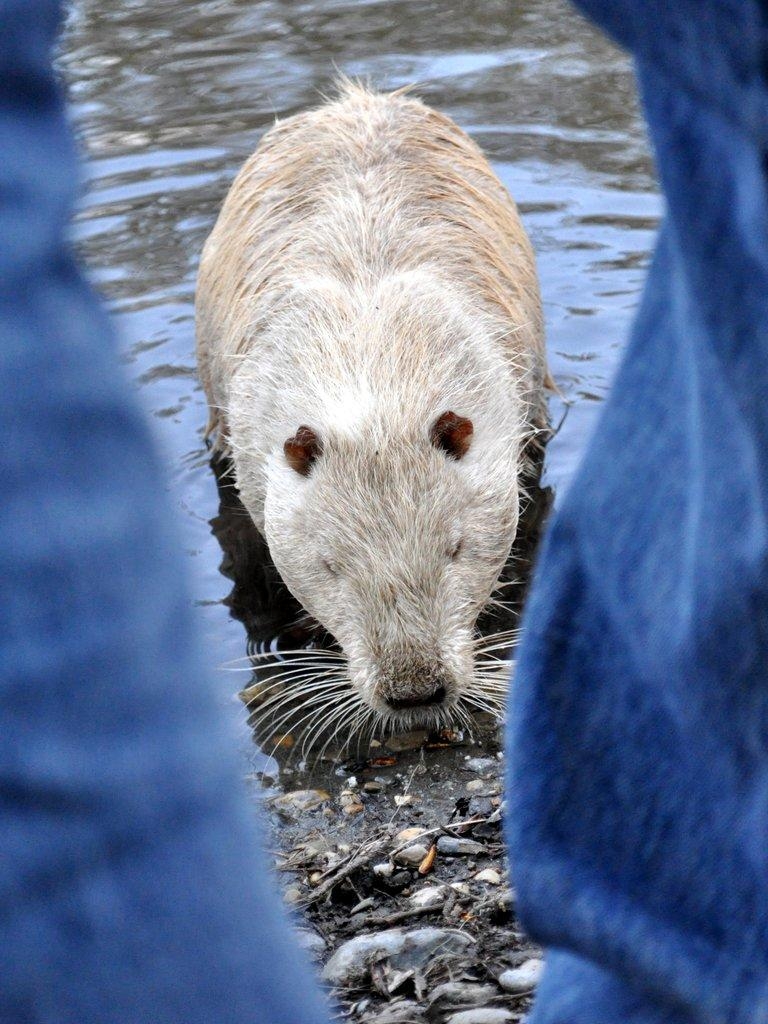What is visible in the foreground of the image? There are legs of a person in the foreground of the image. What can be seen in the background of the image? There is an animal in the water and stones visible on the ground in the background of the image. What type of weather system can be seen in the image? There is no weather system present in the image. What is the iron content of the stones in the image? There is no information about the iron content of the stones in the image. 